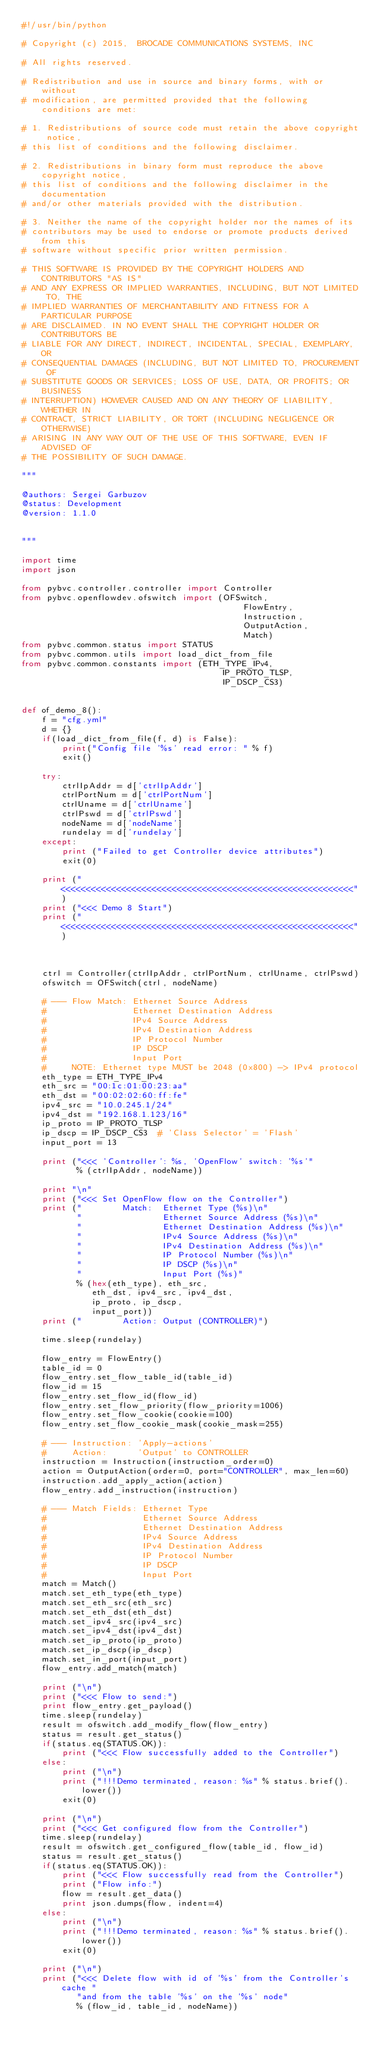Convert code to text. <code><loc_0><loc_0><loc_500><loc_500><_Python_>#!/usr/bin/python

# Copyright (c) 2015,  BROCADE COMMUNICATIONS SYSTEMS, INC

# All rights reserved.

# Redistribution and use in source and binary forms, with or without
# modification, are permitted provided that the following conditions are met:

# 1. Redistributions of source code must retain the above copyright notice,
# this list of conditions and the following disclaimer.

# 2. Redistributions in binary form must reproduce the above copyright notice,
# this list of conditions and the following disclaimer in the documentation
# and/or other materials provided with the distribution.

# 3. Neither the name of the copyright holder nor the names of its
# contributors may be used to endorse or promote products derived from this
# software without specific prior written permission.

# THIS SOFTWARE IS PROVIDED BY THE COPYRIGHT HOLDERS AND CONTRIBUTORS "AS IS"
# AND ANY EXPRESS OR IMPLIED WARRANTIES, INCLUDING, BUT NOT LIMITED TO, THE
# IMPLIED WARRANTIES OF MERCHANTABILITY AND FITNESS FOR A PARTICULAR PURPOSE
# ARE DISCLAIMED. IN NO EVENT SHALL THE COPYRIGHT HOLDER OR CONTRIBUTORS BE
# LIABLE FOR ANY DIRECT, INDIRECT, INCIDENTAL, SPECIAL, EXEMPLARY, OR
# CONSEQUENTIAL DAMAGES (INCLUDING, BUT NOT LIMITED TO, PROCUREMENT OF
# SUBSTITUTE GOODS OR SERVICES; LOSS OF USE, DATA, OR PROFITS; OR BUSINESS
# INTERRUPTION) HOWEVER CAUSED AND ON ANY THEORY OF LIABILITY, WHETHER IN
# CONTRACT, STRICT LIABILITY, OR TORT (INCLUDING NEGLIGENCE OR OTHERWISE)
# ARISING IN ANY WAY OUT OF THE USE OF THIS SOFTWARE, EVEN IF ADVISED OF
# THE POSSIBILITY OF SUCH DAMAGE.

"""

@authors: Sergei Garbuzov
@status: Development
@version: 1.1.0


"""

import time
import json

from pybvc.controller.controller import Controller
from pybvc.openflowdev.ofswitch import (OFSwitch,
                                            FlowEntry,
                                            Instruction,
                                            OutputAction,
                                            Match)
from pybvc.common.status import STATUS
from pybvc.common.utils import load_dict_from_file
from pybvc.common.constants import (ETH_TYPE_IPv4,
                                        IP_PROTO_TLSP,
                                        IP_DSCP_CS3)


def of_demo_8():
    f = "cfg.yml"
    d = {}
    if(load_dict_from_file(f, d) is False):
        print("Config file '%s' read error: " % f)
        exit()

    try:
        ctrlIpAddr = d['ctrlIpAddr']
        ctrlPortNum = d['ctrlPortNum']
        ctrlUname = d['ctrlUname']
        ctrlPswd = d['ctrlPswd']
        nodeName = d['nodeName']
        rundelay = d['rundelay']
    except:
        print ("Failed to get Controller device attributes")
        exit(0)

    print ("<<<<<<<<<<<<<<<<<<<<<<<<<<<<<<<<<<<<<<<<<<<<<<<<<<<<<<<<<<")
    print ("<<< Demo 8 Start")
    print ("<<<<<<<<<<<<<<<<<<<<<<<<<<<<<<<<<<<<<<<<<<<<<<<<<<<<<<<<<<")



    ctrl = Controller(ctrlIpAddr, ctrlPortNum, ctrlUname, ctrlPswd)
    ofswitch = OFSwitch(ctrl, nodeName)

    # --- Flow Match: Ethernet Source Address
    #                 Ethernet Destination Address
    #                 IPv4 Source Address
    #                 IPv4 Destination Address
    #                 IP Protocol Number
    #                 IP DSCP
    #                 Input Port
    #     NOTE: Ethernet type MUST be 2048 (0x800) -> IPv4 protocol
    eth_type = ETH_TYPE_IPv4
    eth_src = "00:1c:01:00:23:aa"
    eth_dst = "00:02:02:60:ff:fe"
    ipv4_src = "10.0.245.1/24"
    ipv4_dst = "192.168.1.123/16"
    ip_proto = IP_PROTO_TLSP
    ip_dscp = IP_DSCP_CS3  # 'Class Selector' = 'Flash'
    input_port = 13

    print ("<<< 'Controller': %s, 'OpenFlow' switch: '%s'"
           % (ctrlIpAddr, nodeName))

    print "\n"
    print ("<<< Set OpenFlow flow on the Controller")
    print ("        Match:  Ethernet Type (%s)\n"
           "                Ethernet Source Address (%s)\n"
           "                Ethernet Destination Address (%s)\n"
           "                IPv4 Source Address (%s)\n"
           "                IPv4 Destination Address (%s)\n"
           "                IP Protocol Number (%s)\n"
           "                IP DSCP (%s)\n"
           "                Input Port (%s)"
           % (hex(eth_type), eth_src,
              eth_dst, ipv4_src, ipv4_dst,
              ip_proto, ip_dscp,
              input_port))
    print ("        Action: Output (CONTROLLER)")

    time.sleep(rundelay)

    flow_entry = FlowEntry()
    table_id = 0
    flow_entry.set_flow_table_id(table_id)
    flow_id = 15
    flow_entry.set_flow_id(flow_id)
    flow_entry.set_flow_priority(flow_priority=1006)
    flow_entry.set_flow_cookie(cookie=100)
    flow_entry.set_flow_cookie_mask(cookie_mask=255)

    # --- Instruction: 'Apply-actions'
    #     Action:      'Output' to CONTROLLER
    instruction = Instruction(instruction_order=0)
    action = OutputAction(order=0, port="CONTROLLER", max_len=60)
    instruction.add_apply_action(action)
    flow_entry.add_instruction(instruction)

    # --- Match Fields: Ethernet Type
    #                   Ethernet Source Address
    #                   Ethernet Destination Address
    #                   IPv4 Source Address
    #                   IPv4 Destination Address
    #                   IP Protocol Number
    #                   IP DSCP
    #                   Input Port
    match = Match()
    match.set_eth_type(eth_type)
    match.set_eth_src(eth_src)
    match.set_eth_dst(eth_dst)
    match.set_ipv4_src(ipv4_src)
    match.set_ipv4_dst(ipv4_dst)
    match.set_ip_proto(ip_proto)
    match.set_ip_dscp(ip_dscp)
    match.set_in_port(input_port)
    flow_entry.add_match(match)

    print ("\n")
    print ("<<< Flow to send:")
    print flow_entry.get_payload()
    time.sleep(rundelay)
    result = ofswitch.add_modify_flow(flow_entry)
    status = result.get_status()
    if(status.eq(STATUS.OK)):
        print ("<<< Flow successfully added to the Controller")
    else:
        print ("\n")
        print ("!!!Demo terminated, reason: %s" % status.brief().lower())
        exit(0)

    print ("\n")
    print ("<<< Get configured flow from the Controller")
    time.sleep(rundelay)
    result = ofswitch.get_configured_flow(table_id, flow_id)
    status = result.get_status()
    if(status.eq(STATUS.OK)):
        print ("<<< Flow successfully read from the Controller")
        print ("Flow info:")
        flow = result.get_data()
        print json.dumps(flow, indent=4)
    else:
        print ("\n")
        print ("!!!Demo terminated, reason: %s" % status.brief().lower())
        exit(0)

    print ("\n")
    print ("<<< Delete flow with id of '%s' from the Controller's cache "
           "and from the table '%s' on the '%s' node"
           % (flow_id, table_id, nodeName))</code> 